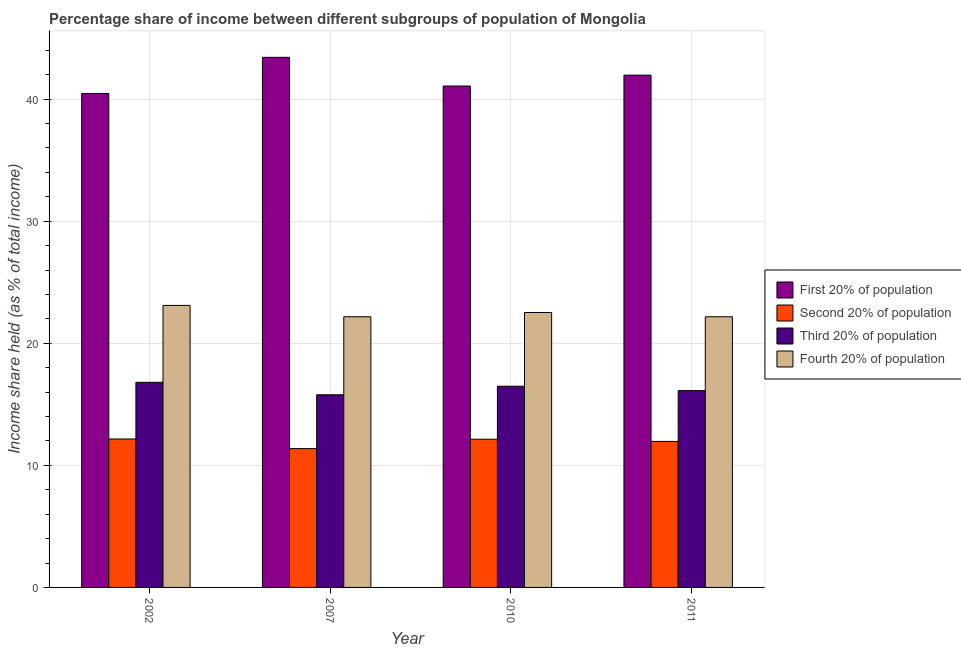Are the number of bars on each tick of the X-axis equal?
Your answer should be compact. Yes. How many bars are there on the 3rd tick from the left?
Your answer should be compact. 4. What is the share of the income held by fourth 20% of the population in 2011?
Make the answer very short. 22.17. Across all years, what is the maximum share of the income held by first 20% of the population?
Ensure brevity in your answer.  43.42. Across all years, what is the minimum share of the income held by second 20% of the population?
Ensure brevity in your answer.  11.37. What is the total share of the income held by third 20% of the population in the graph?
Provide a short and direct response. 65.18. What is the difference between the share of the income held by second 20% of the population in 2007 and that in 2010?
Your response must be concise. -0.77. What is the difference between the share of the income held by second 20% of the population in 2010 and the share of the income held by fourth 20% of the population in 2007?
Make the answer very short. 0.77. What is the average share of the income held by third 20% of the population per year?
Offer a very short reply. 16.3. In the year 2010, what is the difference between the share of the income held by first 20% of the population and share of the income held by fourth 20% of the population?
Give a very brief answer. 0. What is the ratio of the share of the income held by first 20% of the population in 2002 to that in 2007?
Provide a succinct answer. 0.93. Is the difference between the share of the income held by second 20% of the population in 2002 and 2010 greater than the difference between the share of the income held by third 20% of the population in 2002 and 2010?
Offer a terse response. No. What is the difference between the highest and the second highest share of the income held by third 20% of the population?
Your response must be concise. 0.32. What is the difference between the highest and the lowest share of the income held by second 20% of the population?
Offer a very short reply. 0.79. What does the 2nd bar from the left in 2011 represents?
Provide a succinct answer. Second 20% of population. What does the 1st bar from the right in 2011 represents?
Keep it short and to the point. Fourth 20% of population. How many bars are there?
Provide a short and direct response. 16. What is the difference between two consecutive major ticks on the Y-axis?
Give a very brief answer. 10. Does the graph contain any zero values?
Make the answer very short. No. Does the graph contain grids?
Provide a succinct answer. Yes. What is the title of the graph?
Provide a short and direct response. Percentage share of income between different subgroups of population of Mongolia. Does "Overall level" appear as one of the legend labels in the graph?
Ensure brevity in your answer.  No. What is the label or title of the Y-axis?
Ensure brevity in your answer.  Income share held (as % of total income). What is the Income share held (as % of total income) in First 20% of population in 2002?
Ensure brevity in your answer.  40.46. What is the Income share held (as % of total income) of Second 20% of population in 2002?
Provide a short and direct response. 12.16. What is the Income share held (as % of total income) in Fourth 20% of population in 2002?
Your answer should be very brief. 23.1. What is the Income share held (as % of total income) of First 20% of population in 2007?
Your answer should be very brief. 43.42. What is the Income share held (as % of total income) of Second 20% of population in 2007?
Ensure brevity in your answer.  11.37. What is the Income share held (as % of total income) of Third 20% of population in 2007?
Your answer should be compact. 15.78. What is the Income share held (as % of total income) of Fourth 20% of population in 2007?
Offer a very short reply. 22.17. What is the Income share held (as % of total income) in First 20% of population in 2010?
Your response must be concise. 41.07. What is the Income share held (as % of total income) of Second 20% of population in 2010?
Give a very brief answer. 12.14. What is the Income share held (as % of total income) in Third 20% of population in 2010?
Provide a succinct answer. 16.48. What is the Income share held (as % of total income) of Fourth 20% of population in 2010?
Make the answer very short. 22.52. What is the Income share held (as % of total income) in First 20% of population in 2011?
Your answer should be very brief. 41.96. What is the Income share held (as % of total income) in Second 20% of population in 2011?
Ensure brevity in your answer.  11.96. What is the Income share held (as % of total income) of Third 20% of population in 2011?
Make the answer very short. 16.12. What is the Income share held (as % of total income) in Fourth 20% of population in 2011?
Offer a terse response. 22.17. Across all years, what is the maximum Income share held (as % of total income) of First 20% of population?
Your answer should be compact. 43.42. Across all years, what is the maximum Income share held (as % of total income) of Second 20% of population?
Make the answer very short. 12.16. Across all years, what is the maximum Income share held (as % of total income) of Third 20% of population?
Your response must be concise. 16.8. Across all years, what is the maximum Income share held (as % of total income) in Fourth 20% of population?
Offer a very short reply. 23.1. Across all years, what is the minimum Income share held (as % of total income) of First 20% of population?
Your answer should be compact. 40.46. Across all years, what is the minimum Income share held (as % of total income) of Second 20% of population?
Make the answer very short. 11.37. Across all years, what is the minimum Income share held (as % of total income) of Third 20% of population?
Your answer should be compact. 15.78. Across all years, what is the minimum Income share held (as % of total income) of Fourth 20% of population?
Your answer should be compact. 22.17. What is the total Income share held (as % of total income) in First 20% of population in the graph?
Keep it short and to the point. 166.91. What is the total Income share held (as % of total income) of Second 20% of population in the graph?
Your answer should be compact. 47.63. What is the total Income share held (as % of total income) of Third 20% of population in the graph?
Your response must be concise. 65.18. What is the total Income share held (as % of total income) in Fourth 20% of population in the graph?
Keep it short and to the point. 89.96. What is the difference between the Income share held (as % of total income) of First 20% of population in 2002 and that in 2007?
Offer a very short reply. -2.96. What is the difference between the Income share held (as % of total income) of Second 20% of population in 2002 and that in 2007?
Your answer should be compact. 0.79. What is the difference between the Income share held (as % of total income) in Fourth 20% of population in 2002 and that in 2007?
Give a very brief answer. 0.93. What is the difference between the Income share held (as % of total income) of First 20% of population in 2002 and that in 2010?
Your response must be concise. -0.61. What is the difference between the Income share held (as % of total income) in Third 20% of population in 2002 and that in 2010?
Provide a succinct answer. 0.32. What is the difference between the Income share held (as % of total income) in Fourth 20% of population in 2002 and that in 2010?
Ensure brevity in your answer.  0.58. What is the difference between the Income share held (as % of total income) in Third 20% of population in 2002 and that in 2011?
Make the answer very short. 0.68. What is the difference between the Income share held (as % of total income) of Fourth 20% of population in 2002 and that in 2011?
Give a very brief answer. 0.93. What is the difference between the Income share held (as % of total income) of First 20% of population in 2007 and that in 2010?
Keep it short and to the point. 2.35. What is the difference between the Income share held (as % of total income) in Second 20% of population in 2007 and that in 2010?
Your answer should be compact. -0.77. What is the difference between the Income share held (as % of total income) in Third 20% of population in 2007 and that in 2010?
Give a very brief answer. -0.7. What is the difference between the Income share held (as % of total income) in Fourth 20% of population in 2007 and that in 2010?
Give a very brief answer. -0.35. What is the difference between the Income share held (as % of total income) of First 20% of population in 2007 and that in 2011?
Your response must be concise. 1.46. What is the difference between the Income share held (as % of total income) of Second 20% of population in 2007 and that in 2011?
Your response must be concise. -0.59. What is the difference between the Income share held (as % of total income) in Third 20% of population in 2007 and that in 2011?
Make the answer very short. -0.34. What is the difference between the Income share held (as % of total income) in First 20% of population in 2010 and that in 2011?
Offer a terse response. -0.89. What is the difference between the Income share held (as % of total income) in Second 20% of population in 2010 and that in 2011?
Ensure brevity in your answer.  0.18. What is the difference between the Income share held (as % of total income) in Third 20% of population in 2010 and that in 2011?
Your response must be concise. 0.36. What is the difference between the Income share held (as % of total income) of Fourth 20% of population in 2010 and that in 2011?
Give a very brief answer. 0.35. What is the difference between the Income share held (as % of total income) in First 20% of population in 2002 and the Income share held (as % of total income) in Second 20% of population in 2007?
Offer a terse response. 29.09. What is the difference between the Income share held (as % of total income) in First 20% of population in 2002 and the Income share held (as % of total income) in Third 20% of population in 2007?
Make the answer very short. 24.68. What is the difference between the Income share held (as % of total income) of First 20% of population in 2002 and the Income share held (as % of total income) of Fourth 20% of population in 2007?
Keep it short and to the point. 18.29. What is the difference between the Income share held (as % of total income) in Second 20% of population in 2002 and the Income share held (as % of total income) in Third 20% of population in 2007?
Your answer should be very brief. -3.62. What is the difference between the Income share held (as % of total income) in Second 20% of population in 2002 and the Income share held (as % of total income) in Fourth 20% of population in 2007?
Offer a terse response. -10.01. What is the difference between the Income share held (as % of total income) in Third 20% of population in 2002 and the Income share held (as % of total income) in Fourth 20% of population in 2007?
Your answer should be very brief. -5.37. What is the difference between the Income share held (as % of total income) of First 20% of population in 2002 and the Income share held (as % of total income) of Second 20% of population in 2010?
Offer a very short reply. 28.32. What is the difference between the Income share held (as % of total income) in First 20% of population in 2002 and the Income share held (as % of total income) in Third 20% of population in 2010?
Provide a short and direct response. 23.98. What is the difference between the Income share held (as % of total income) of First 20% of population in 2002 and the Income share held (as % of total income) of Fourth 20% of population in 2010?
Ensure brevity in your answer.  17.94. What is the difference between the Income share held (as % of total income) of Second 20% of population in 2002 and the Income share held (as % of total income) of Third 20% of population in 2010?
Your response must be concise. -4.32. What is the difference between the Income share held (as % of total income) of Second 20% of population in 2002 and the Income share held (as % of total income) of Fourth 20% of population in 2010?
Make the answer very short. -10.36. What is the difference between the Income share held (as % of total income) in Third 20% of population in 2002 and the Income share held (as % of total income) in Fourth 20% of population in 2010?
Make the answer very short. -5.72. What is the difference between the Income share held (as % of total income) in First 20% of population in 2002 and the Income share held (as % of total income) in Third 20% of population in 2011?
Offer a terse response. 24.34. What is the difference between the Income share held (as % of total income) of First 20% of population in 2002 and the Income share held (as % of total income) of Fourth 20% of population in 2011?
Offer a very short reply. 18.29. What is the difference between the Income share held (as % of total income) of Second 20% of population in 2002 and the Income share held (as % of total income) of Third 20% of population in 2011?
Make the answer very short. -3.96. What is the difference between the Income share held (as % of total income) of Second 20% of population in 2002 and the Income share held (as % of total income) of Fourth 20% of population in 2011?
Give a very brief answer. -10.01. What is the difference between the Income share held (as % of total income) in Third 20% of population in 2002 and the Income share held (as % of total income) in Fourth 20% of population in 2011?
Keep it short and to the point. -5.37. What is the difference between the Income share held (as % of total income) in First 20% of population in 2007 and the Income share held (as % of total income) in Second 20% of population in 2010?
Your answer should be very brief. 31.28. What is the difference between the Income share held (as % of total income) in First 20% of population in 2007 and the Income share held (as % of total income) in Third 20% of population in 2010?
Make the answer very short. 26.94. What is the difference between the Income share held (as % of total income) in First 20% of population in 2007 and the Income share held (as % of total income) in Fourth 20% of population in 2010?
Provide a short and direct response. 20.9. What is the difference between the Income share held (as % of total income) in Second 20% of population in 2007 and the Income share held (as % of total income) in Third 20% of population in 2010?
Your answer should be very brief. -5.11. What is the difference between the Income share held (as % of total income) in Second 20% of population in 2007 and the Income share held (as % of total income) in Fourth 20% of population in 2010?
Keep it short and to the point. -11.15. What is the difference between the Income share held (as % of total income) of Third 20% of population in 2007 and the Income share held (as % of total income) of Fourth 20% of population in 2010?
Your answer should be compact. -6.74. What is the difference between the Income share held (as % of total income) of First 20% of population in 2007 and the Income share held (as % of total income) of Second 20% of population in 2011?
Give a very brief answer. 31.46. What is the difference between the Income share held (as % of total income) in First 20% of population in 2007 and the Income share held (as % of total income) in Third 20% of population in 2011?
Provide a succinct answer. 27.3. What is the difference between the Income share held (as % of total income) of First 20% of population in 2007 and the Income share held (as % of total income) of Fourth 20% of population in 2011?
Provide a succinct answer. 21.25. What is the difference between the Income share held (as % of total income) in Second 20% of population in 2007 and the Income share held (as % of total income) in Third 20% of population in 2011?
Your answer should be very brief. -4.75. What is the difference between the Income share held (as % of total income) in Second 20% of population in 2007 and the Income share held (as % of total income) in Fourth 20% of population in 2011?
Keep it short and to the point. -10.8. What is the difference between the Income share held (as % of total income) of Third 20% of population in 2007 and the Income share held (as % of total income) of Fourth 20% of population in 2011?
Your response must be concise. -6.39. What is the difference between the Income share held (as % of total income) in First 20% of population in 2010 and the Income share held (as % of total income) in Second 20% of population in 2011?
Offer a terse response. 29.11. What is the difference between the Income share held (as % of total income) of First 20% of population in 2010 and the Income share held (as % of total income) of Third 20% of population in 2011?
Offer a terse response. 24.95. What is the difference between the Income share held (as % of total income) of Second 20% of population in 2010 and the Income share held (as % of total income) of Third 20% of population in 2011?
Your answer should be very brief. -3.98. What is the difference between the Income share held (as % of total income) in Second 20% of population in 2010 and the Income share held (as % of total income) in Fourth 20% of population in 2011?
Your response must be concise. -10.03. What is the difference between the Income share held (as % of total income) of Third 20% of population in 2010 and the Income share held (as % of total income) of Fourth 20% of population in 2011?
Your answer should be compact. -5.69. What is the average Income share held (as % of total income) of First 20% of population per year?
Your answer should be very brief. 41.73. What is the average Income share held (as % of total income) in Second 20% of population per year?
Keep it short and to the point. 11.91. What is the average Income share held (as % of total income) of Third 20% of population per year?
Offer a terse response. 16.3. What is the average Income share held (as % of total income) in Fourth 20% of population per year?
Provide a succinct answer. 22.49. In the year 2002, what is the difference between the Income share held (as % of total income) of First 20% of population and Income share held (as % of total income) of Second 20% of population?
Offer a very short reply. 28.3. In the year 2002, what is the difference between the Income share held (as % of total income) of First 20% of population and Income share held (as % of total income) of Third 20% of population?
Offer a very short reply. 23.66. In the year 2002, what is the difference between the Income share held (as % of total income) of First 20% of population and Income share held (as % of total income) of Fourth 20% of population?
Your response must be concise. 17.36. In the year 2002, what is the difference between the Income share held (as % of total income) of Second 20% of population and Income share held (as % of total income) of Third 20% of population?
Offer a very short reply. -4.64. In the year 2002, what is the difference between the Income share held (as % of total income) in Second 20% of population and Income share held (as % of total income) in Fourth 20% of population?
Make the answer very short. -10.94. In the year 2007, what is the difference between the Income share held (as % of total income) in First 20% of population and Income share held (as % of total income) in Second 20% of population?
Provide a succinct answer. 32.05. In the year 2007, what is the difference between the Income share held (as % of total income) in First 20% of population and Income share held (as % of total income) in Third 20% of population?
Give a very brief answer. 27.64. In the year 2007, what is the difference between the Income share held (as % of total income) in First 20% of population and Income share held (as % of total income) in Fourth 20% of population?
Ensure brevity in your answer.  21.25. In the year 2007, what is the difference between the Income share held (as % of total income) in Second 20% of population and Income share held (as % of total income) in Third 20% of population?
Keep it short and to the point. -4.41. In the year 2007, what is the difference between the Income share held (as % of total income) in Third 20% of population and Income share held (as % of total income) in Fourth 20% of population?
Provide a short and direct response. -6.39. In the year 2010, what is the difference between the Income share held (as % of total income) in First 20% of population and Income share held (as % of total income) in Second 20% of population?
Ensure brevity in your answer.  28.93. In the year 2010, what is the difference between the Income share held (as % of total income) in First 20% of population and Income share held (as % of total income) in Third 20% of population?
Ensure brevity in your answer.  24.59. In the year 2010, what is the difference between the Income share held (as % of total income) of First 20% of population and Income share held (as % of total income) of Fourth 20% of population?
Provide a succinct answer. 18.55. In the year 2010, what is the difference between the Income share held (as % of total income) of Second 20% of population and Income share held (as % of total income) of Third 20% of population?
Your response must be concise. -4.34. In the year 2010, what is the difference between the Income share held (as % of total income) in Second 20% of population and Income share held (as % of total income) in Fourth 20% of population?
Your answer should be compact. -10.38. In the year 2010, what is the difference between the Income share held (as % of total income) in Third 20% of population and Income share held (as % of total income) in Fourth 20% of population?
Keep it short and to the point. -6.04. In the year 2011, what is the difference between the Income share held (as % of total income) of First 20% of population and Income share held (as % of total income) of Third 20% of population?
Provide a short and direct response. 25.84. In the year 2011, what is the difference between the Income share held (as % of total income) of First 20% of population and Income share held (as % of total income) of Fourth 20% of population?
Give a very brief answer. 19.79. In the year 2011, what is the difference between the Income share held (as % of total income) in Second 20% of population and Income share held (as % of total income) in Third 20% of population?
Offer a terse response. -4.16. In the year 2011, what is the difference between the Income share held (as % of total income) in Second 20% of population and Income share held (as % of total income) in Fourth 20% of population?
Your answer should be compact. -10.21. In the year 2011, what is the difference between the Income share held (as % of total income) in Third 20% of population and Income share held (as % of total income) in Fourth 20% of population?
Make the answer very short. -6.05. What is the ratio of the Income share held (as % of total income) of First 20% of population in 2002 to that in 2007?
Provide a short and direct response. 0.93. What is the ratio of the Income share held (as % of total income) of Second 20% of population in 2002 to that in 2007?
Your answer should be compact. 1.07. What is the ratio of the Income share held (as % of total income) of Third 20% of population in 2002 to that in 2007?
Keep it short and to the point. 1.06. What is the ratio of the Income share held (as % of total income) in Fourth 20% of population in 2002 to that in 2007?
Your answer should be very brief. 1.04. What is the ratio of the Income share held (as % of total income) of First 20% of population in 2002 to that in 2010?
Your answer should be very brief. 0.99. What is the ratio of the Income share held (as % of total income) of Second 20% of population in 2002 to that in 2010?
Provide a short and direct response. 1. What is the ratio of the Income share held (as % of total income) in Third 20% of population in 2002 to that in 2010?
Your response must be concise. 1.02. What is the ratio of the Income share held (as % of total income) in Fourth 20% of population in 2002 to that in 2010?
Keep it short and to the point. 1.03. What is the ratio of the Income share held (as % of total income) in Second 20% of population in 2002 to that in 2011?
Keep it short and to the point. 1.02. What is the ratio of the Income share held (as % of total income) in Third 20% of population in 2002 to that in 2011?
Ensure brevity in your answer.  1.04. What is the ratio of the Income share held (as % of total income) of Fourth 20% of population in 2002 to that in 2011?
Provide a succinct answer. 1.04. What is the ratio of the Income share held (as % of total income) of First 20% of population in 2007 to that in 2010?
Make the answer very short. 1.06. What is the ratio of the Income share held (as % of total income) in Second 20% of population in 2007 to that in 2010?
Provide a short and direct response. 0.94. What is the ratio of the Income share held (as % of total income) in Third 20% of population in 2007 to that in 2010?
Ensure brevity in your answer.  0.96. What is the ratio of the Income share held (as % of total income) in Fourth 20% of population in 2007 to that in 2010?
Ensure brevity in your answer.  0.98. What is the ratio of the Income share held (as % of total income) in First 20% of population in 2007 to that in 2011?
Provide a short and direct response. 1.03. What is the ratio of the Income share held (as % of total income) of Second 20% of population in 2007 to that in 2011?
Your answer should be very brief. 0.95. What is the ratio of the Income share held (as % of total income) in Third 20% of population in 2007 to that in 2011?
Provide a short and direct response. 0.98. What is the ratio of the Income share held (as % of total income) in Fourth 20% of population in 2007 to that in 2011?
Give a very brief answer. 1. What is the ratio of the Income share held (as % of total income) in First 20% of population in 2010 to that in 2011?
Offer a very short reply. 0.98. What is the ratio of the Income share held (as % of total income) in Second 20% of population in 2010 to that in 2011?
Keep it short and to the point. 1.02. What is the ratio of the Income share held (as % of total income) in Third 20% of population in 2010 to that in 2011?
Offer a terse response. 1.02. What is the ratio of the Income share held (as % of total income) in Fourth 20% of population in 2010 to that in 2011?
Your answer should be compact. 1.02. What is the difference between the highest and the second highest Income share held (as % of total income) in First 20% of population?
Ensure brevity in your answer.  1.46. What is the difference between the highest and the second highest Income share held (as % of total income) in Second 20% of population?
Give a very brief answer. 0.02. What is the difference between the highest and the second highest Income share held (as % of total income) in Third 20% of population?
Provide a short and direct response. 0.32. What is the difference between the highest and the second highest Income share held (as % of total income) in Fourth 20% of population?
Offer a very short reply. 0.58. What is the difference between the highest and the lowest Income share held (as % of total income) in First 20% of population?
Give a very brief answer. 2.96. What is the difference between the highest and the lowest Income share held (as % of total income) of Second 20% of population?
Give a very brief answer. 0.79. What is the difference between the highest and the lowest Income share held (as % of total income) in Third 20% of population?
Provide a short and direct response. 1.02. 